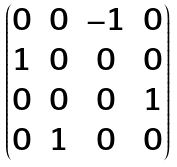Convert formula to latex. <formula><loc_0><loc_0><loc_500><loc_500>\begin{pmatrix} 0 & 0 & - 1 & 0 \\ 1 & 0 & 0 & 0 \\ 0 & 0 & 0 & 1 \\ 0 & 1 & 0 & 0 \end{pmatrix}</formula> 